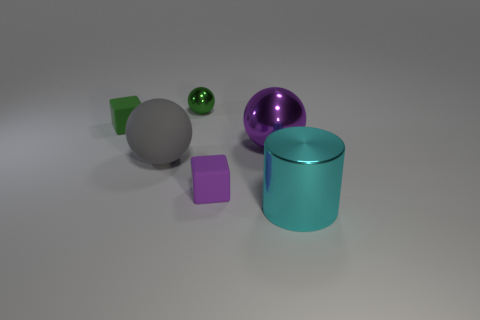Subtract all small balls. How many balls are left? 2 Subtract all purple balls. How many balls are left? 2 Add 2 tiny spheres. How many objects exist? 8 Subtract all cylinders. How many objects are left? 5 Subtract 1 spheres. How many spheres are left? 2 Subtract all green cylinders. How many yellow cubes are left? 0 Subtract all tiny metal things. Subtract all green objects. How many objects are left? 3 Add 1 small purple blocks. How many small purple blocks are left? 2 Add 4 small metal balls. How many small metal balls exist? 5 Subtract 1 gray spheres. How many objects are left? 5 